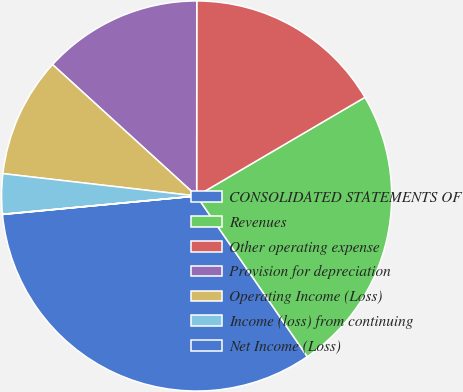<chart> <loc_0><loc_0><loc_500><loc_500><pie_chart><fcel>CONSOLIDATED STATEMENTS OF<fcel>Revenues<fcel>Other operating expense<fcel>Provision for depreciation<fcel>Operating Income (Loss)<fcel>Income (loss) from continuing<fcel>Net Income (Loss)<nl><fcel>33.09%<fcel>23.84%<fcel>16.55%<fcel>13.24%<fcel>9.94%<fcel>3.32%<fcel>0.02%<nl></chart> 